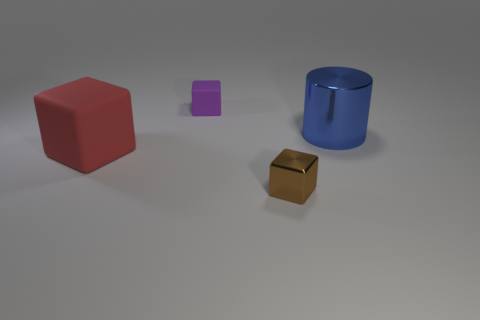Subtract all brown cylinders. Subtract all brown spheres. How many cylinders are left? 1 Add 1 tiny red metal blocks. How many objects exist? 5 Subtract all cubes. How many objects are left? 1 Add 3 small matte cylinders. How many small matte cylinders exist? 3 Subtract 0 yellow cylinders. How many objects are left? 4 Subtract all purple matte blocks. Subtract all tiny brown objects. How many objects are left? 2 Add 1 big metallic cylinders. How many big metallic cylinders are left? 2 